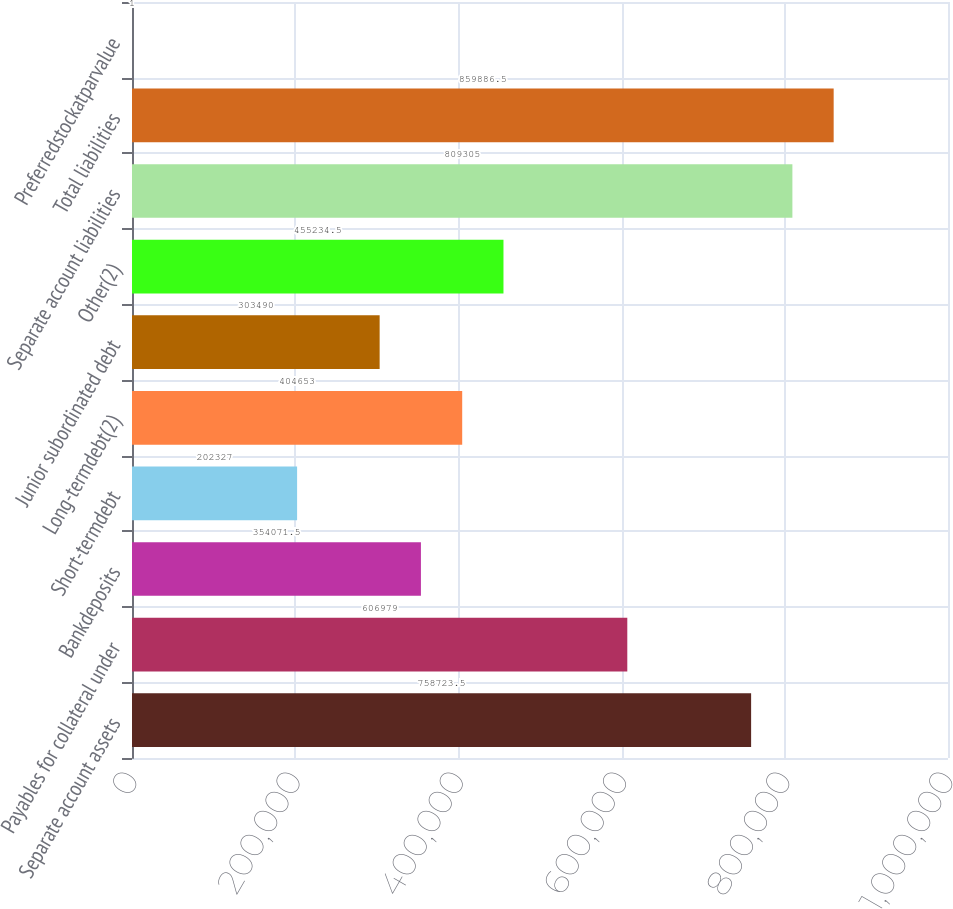Convert chart to OTSL. <chart><loc_0><loc_0><loc_500><loc_500><bar_chart><fcel>Separate account assets<fcel>Payables for collateral under<fcel>Bankdeposits<fcel>Short-termdebt<fcel>Long-termdebt(2)<fcel>Junior subordinated debt<fcel>Other(2)<fcel>Separate account liabilities<fcel>Total liabilities<fcel>Preferredstockatparvalue<nl><fcel>758724<fcel>606979<fcel>354072<fcel>202327<fcel>404653<fcel>303490<fcel>455234<fcel>809305<fcel>859886<fcel>1<nl></chart> 